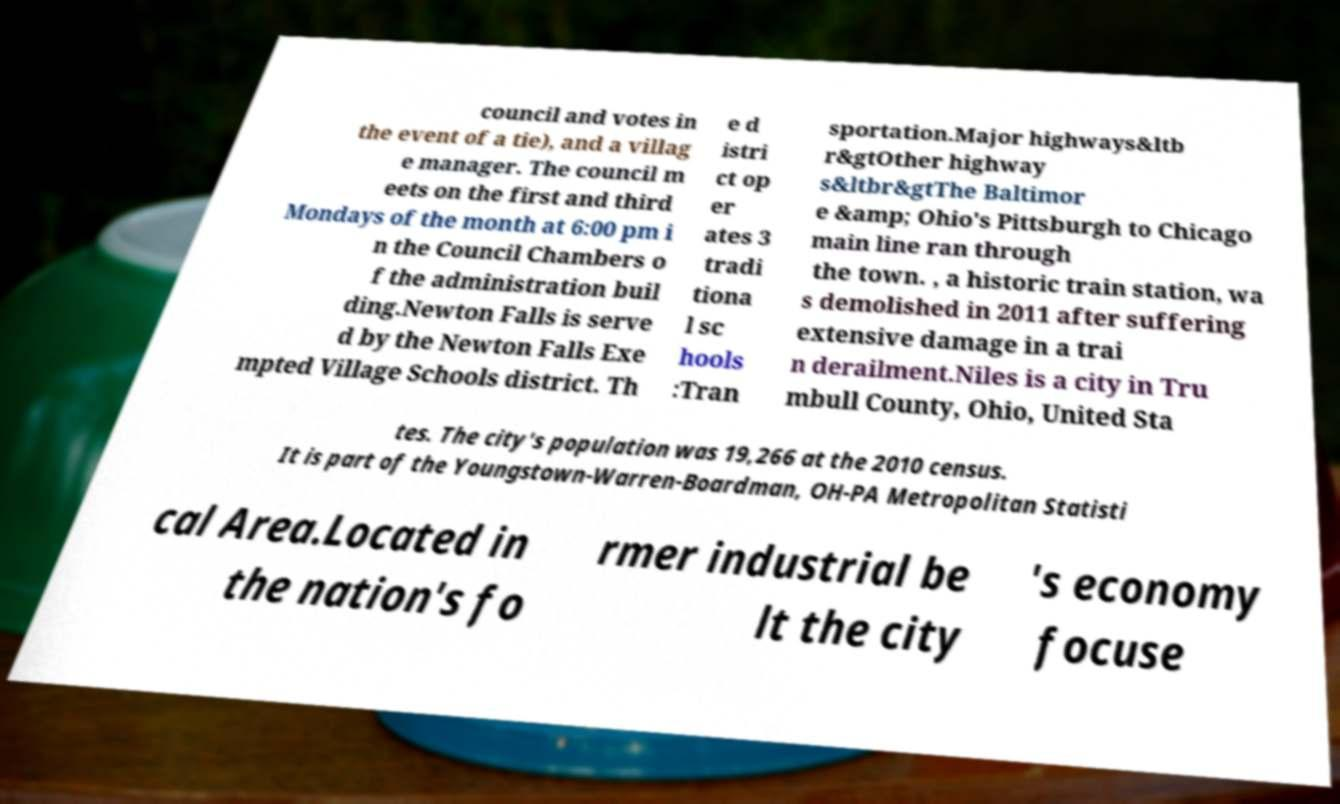Could you extract and type out the text from this image? council and votes in the event of a tie), and a villag e manager. The council m eets on the first and third Mondays of the month at 6:00 pm i n the Council Chambers o f the administration buil ding.Newton Falls is serve d by the Newton Falls Exe mpted Village Schools district. Th e d istri ct op er ates 3 tradi tiona l sc hools :Tran sportation.Major highways&ltb r&gtOther highway s&ltbr&gtThe Baltimor e &amp; Ohio's Pittsburgh to Chicago main line ran through the town. , a historic train station, wa s demolished in 2011 after suffering extensive damage in a trai n derailment.Niles is a city in Tru mbull County, Ohio, United Sta tes. The city's population was 19,266 at the 2010 census. It is part of the Youngstown-Warren-Boardman, OH-PA Metropolitan Statisti cal Area.Located in the nation's fo rmer industrial be lt the city 's economy focuse 